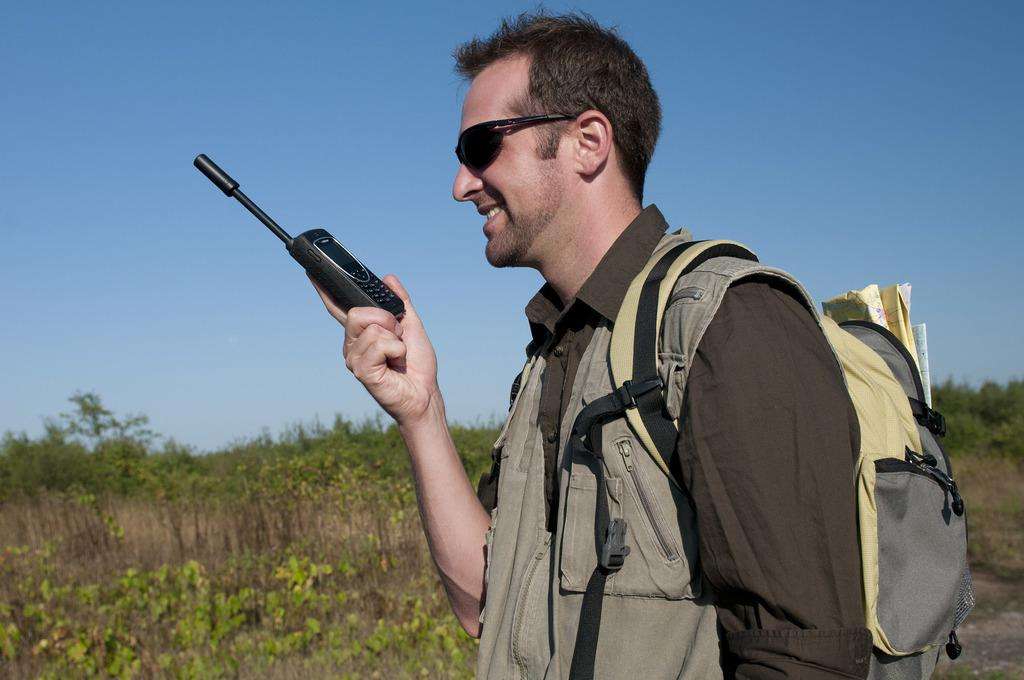Who is present in the image? There is a man in the image. What is the man doing in the image? The man is standing and smiling. What object is the man holding in his hand? The man is holding a walkie talkie in his hand. What can be seen in the background of the image? There are trees and the sky visible in the background of the image. What type of machine is the man operating in the image? There is no machine present in the image; the man is holding a walkie talkie. What company does the man represent in the image? There is no indication of a company in the image. 